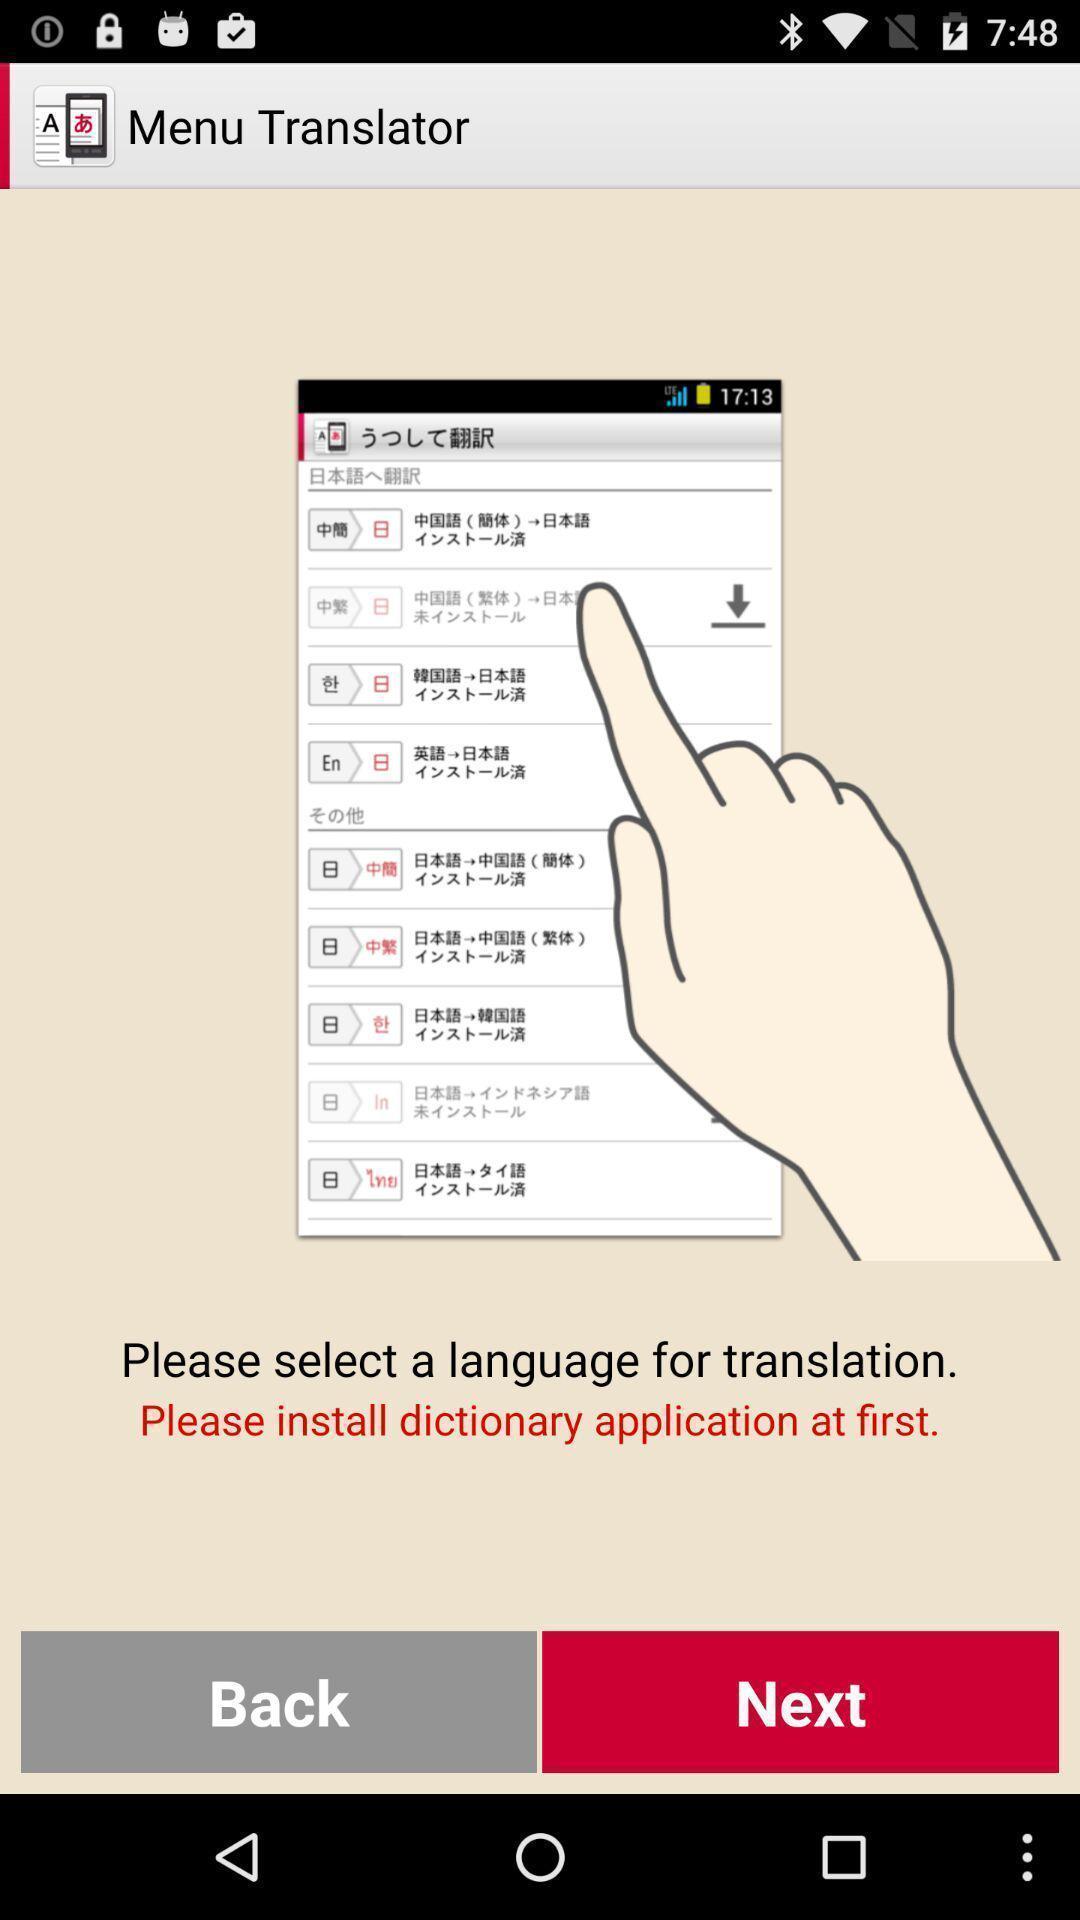Give me a summary of this screen capture. Welcome page of a learning app. 